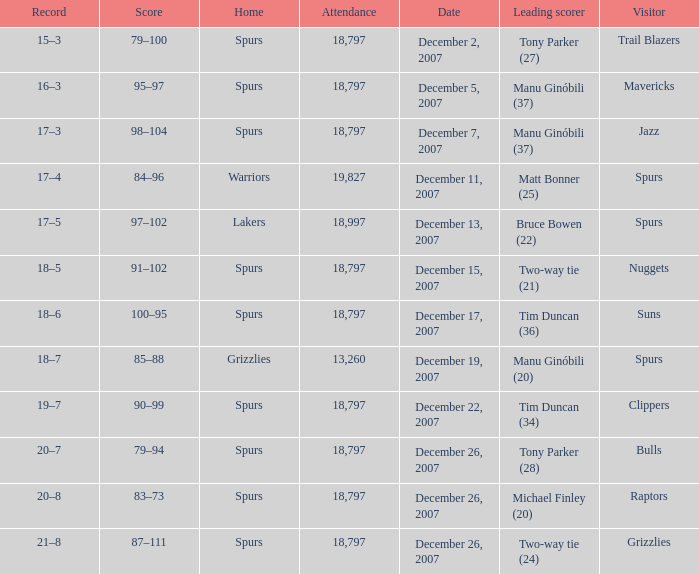What is the record of the game on December 5, 2007? 16–3. Would you mind parsing the complete table? {'header': ['Record', 'Score', 'Home', 'Attendance', 'Date', 'Leading scorer', 'Visitor'], 'rows': [['15–3', '79–100', 'Spurs', '18,797', 'December 2, 2007', 'Tony Parker (27)', 'Trail Blazers'], ['16–3', '95–97', 'Spurs', '18,797', 'December 5, 2007', 'Manu Ginóbili (37)', 'Mavericks'], ['17–3', '98–104', 'Spurs', '18,797', 'December 7, 2007', 'Manu Ginóbili (37)', 'Jazz'], ['17–4', '84–96', 'Warriors', '19,827', 'December 11, 2007', 'Matt Bonner (25)', 'Spurs'], ['17–5', '97–102', 'Lakers', '18,997', 'December 13, 2007', 'Bruce Bowen (22)', 'Spurs'], ['18–5', '91–102', 'Spurs', '18,797', 'December 15, 2007', 'Two-way tie (21)', 'Nuggets'], ['18–6', '100–95', 'Spurs', '18,797', 'December 17, 2007', 'Tim Duncan (36)', 'Suns'], ['18–7', '85–88', 'Grizzlies', '13,260', 'December 19, 2007', 'Manu Ginóbili (20)', 'Spurs'], ['19–7', '90–99', 'Spurs', '18,797', 'December 22, 2007', 'Tim Duncan (34)', 'Clippers'], ['20–7', '79–94', 'Spurs', '18,797', 'December 26, 2007', 'Tony Parker (28)', 'Bulls'], ['20–8', '83–73', 'Spurs', '18,797', 'December 26, 2007', 'Michael Finley (20)', 'Raptors'], ['21–8', '87–111', 'Spurs', '18,797', 'December 26, 2007', 'Two-way tie (24)', 'Grizzlies']]} 